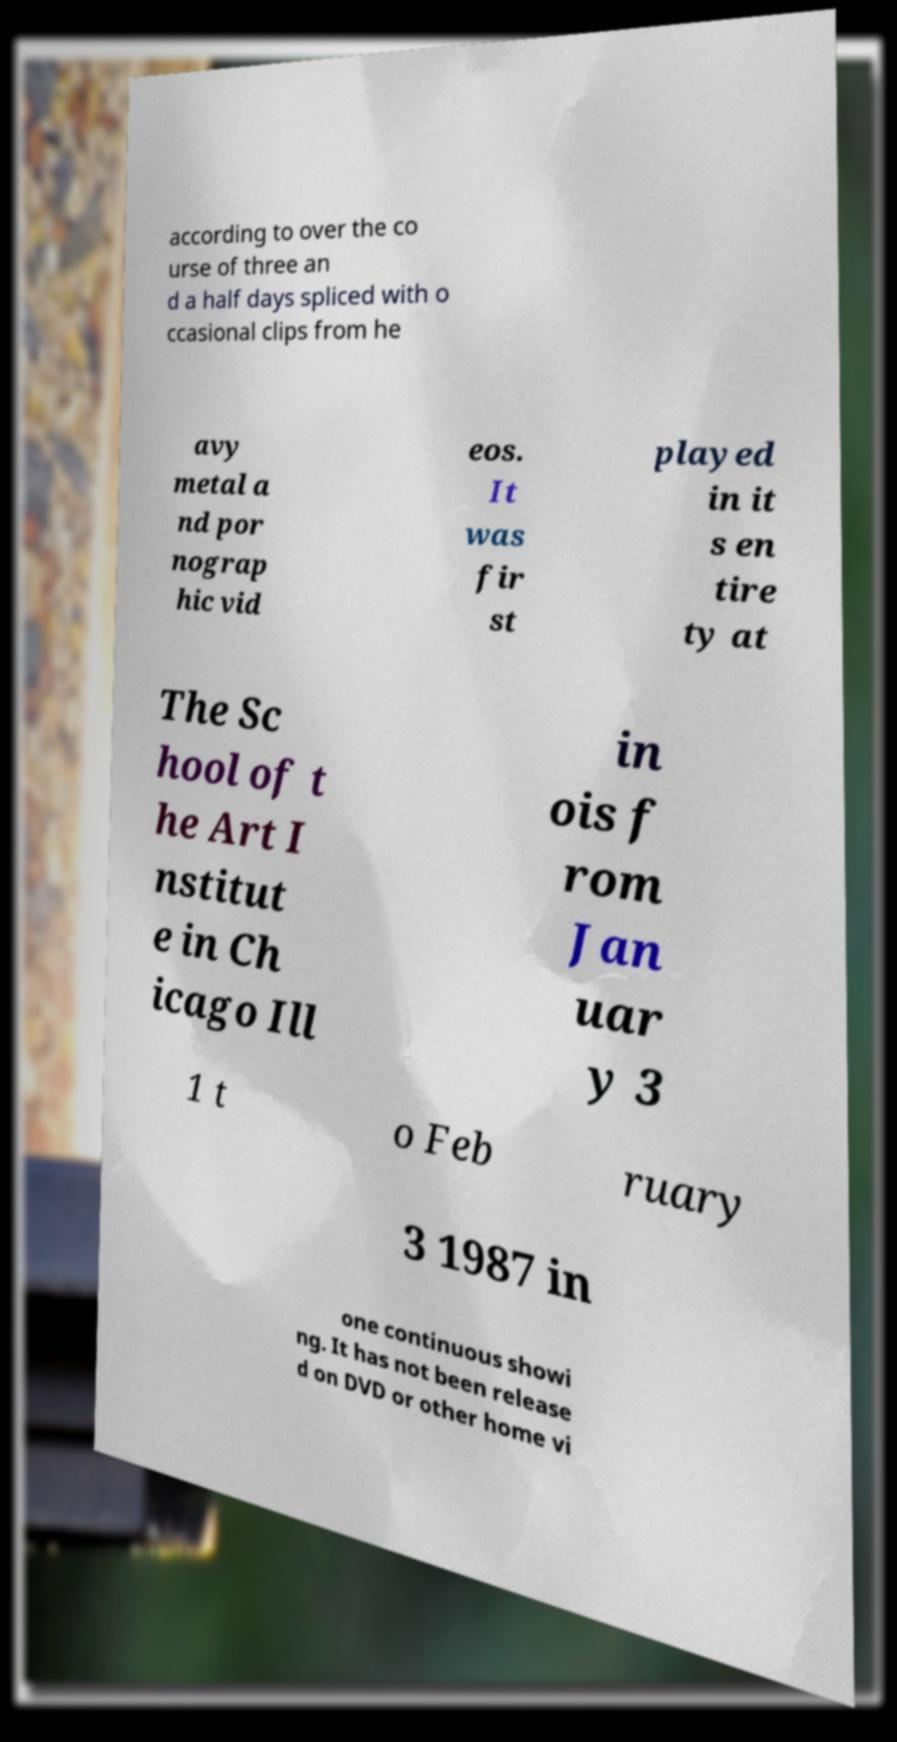There's text embedded in this image that I need extracted. Can you transcribe it verbatim? according to over the co urse of three an d a half days spliced with o ccasional clips from he avy metal a nd por nograp hic vid eos. It was fir st played in it s en tire ty at The Sc hool of t he Art I nstitut e in Ch icago Ill in ois f rom Jan uar y 3 1 t o Feb ruary 3 1987 in one continuous showi ng. It has not been release d on DVD or other home vi 